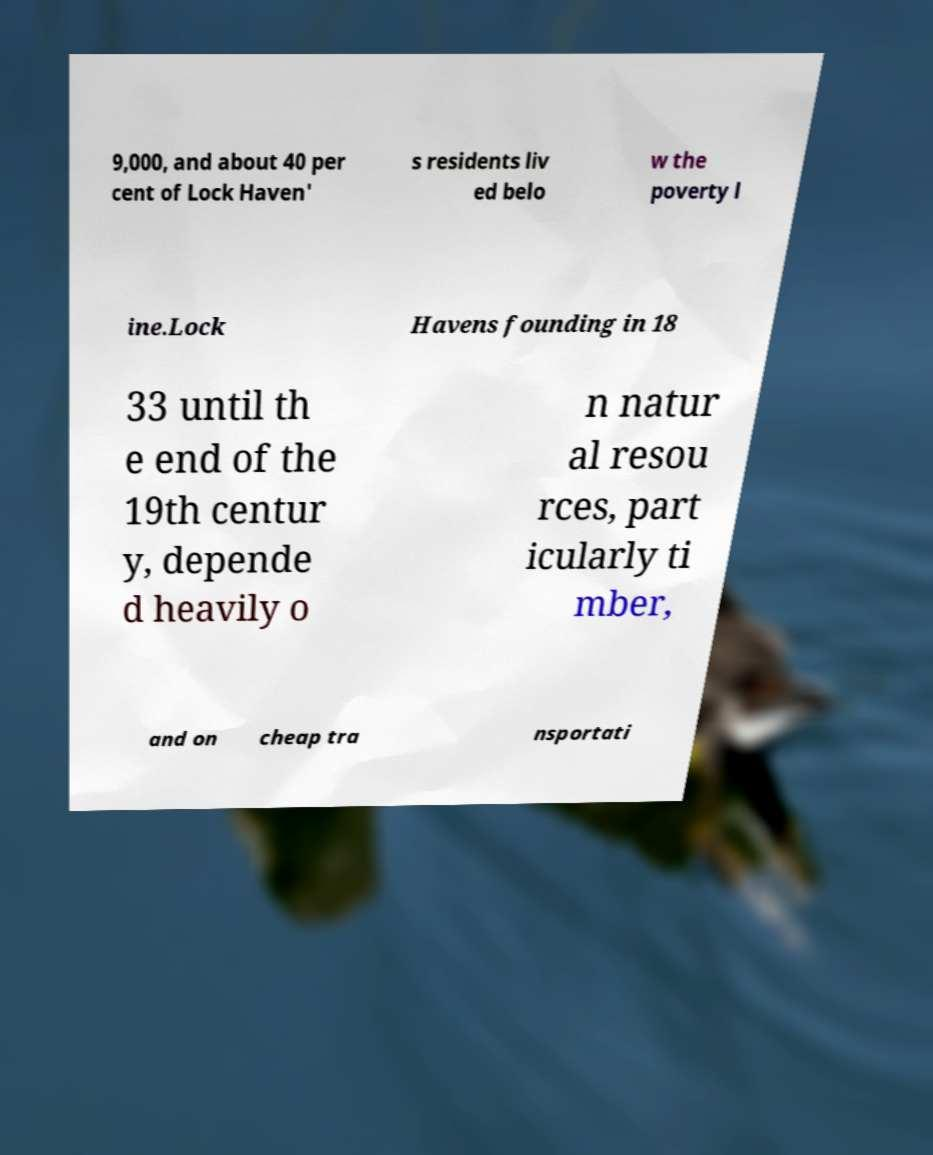Can you accurately transcribe the text from the provided image for me? 9,000, and about 40 per cent of Lock Haven' s residents liv ed belo w the poverty l ine.Lock Havens founding in 18 33 until th e end of the 19th centur y, depende d heavily o n natur al resou rces, part icularly ti mber, and on cheap tra nsportati 